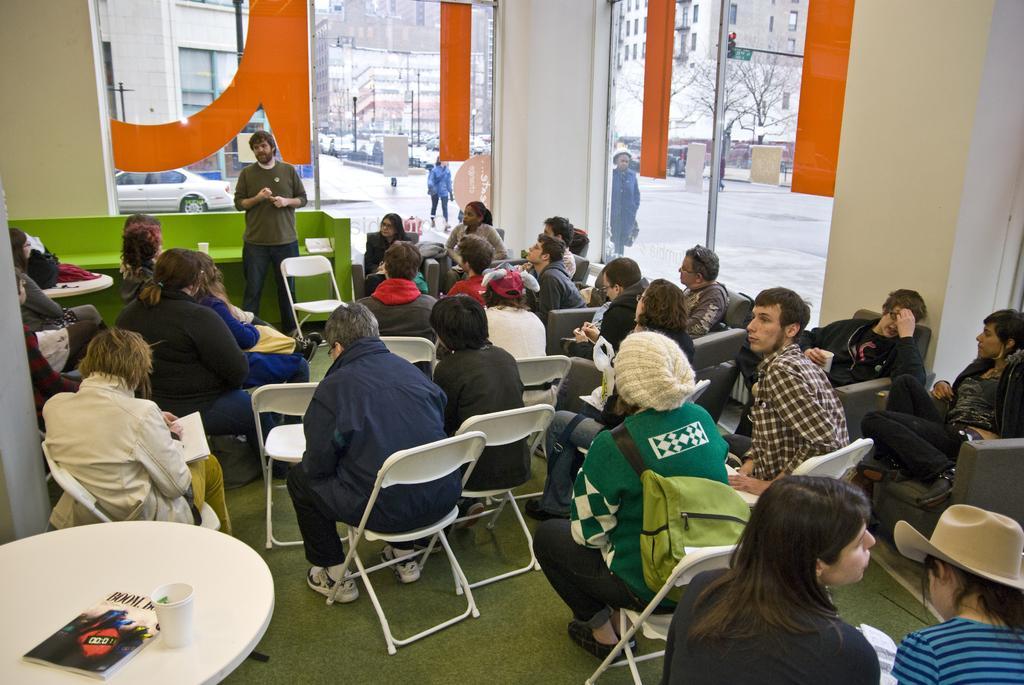In one or two sentences, can you explain what this image depicts? This Picture describe as a in side view of the class room in which group of boys and girls are sitting on the chair and listening to the speech given by the man who is wearing brown full sleeve t-shirt and jean, behind we can see a glass from which road, tree, signal and building are seen through it. 